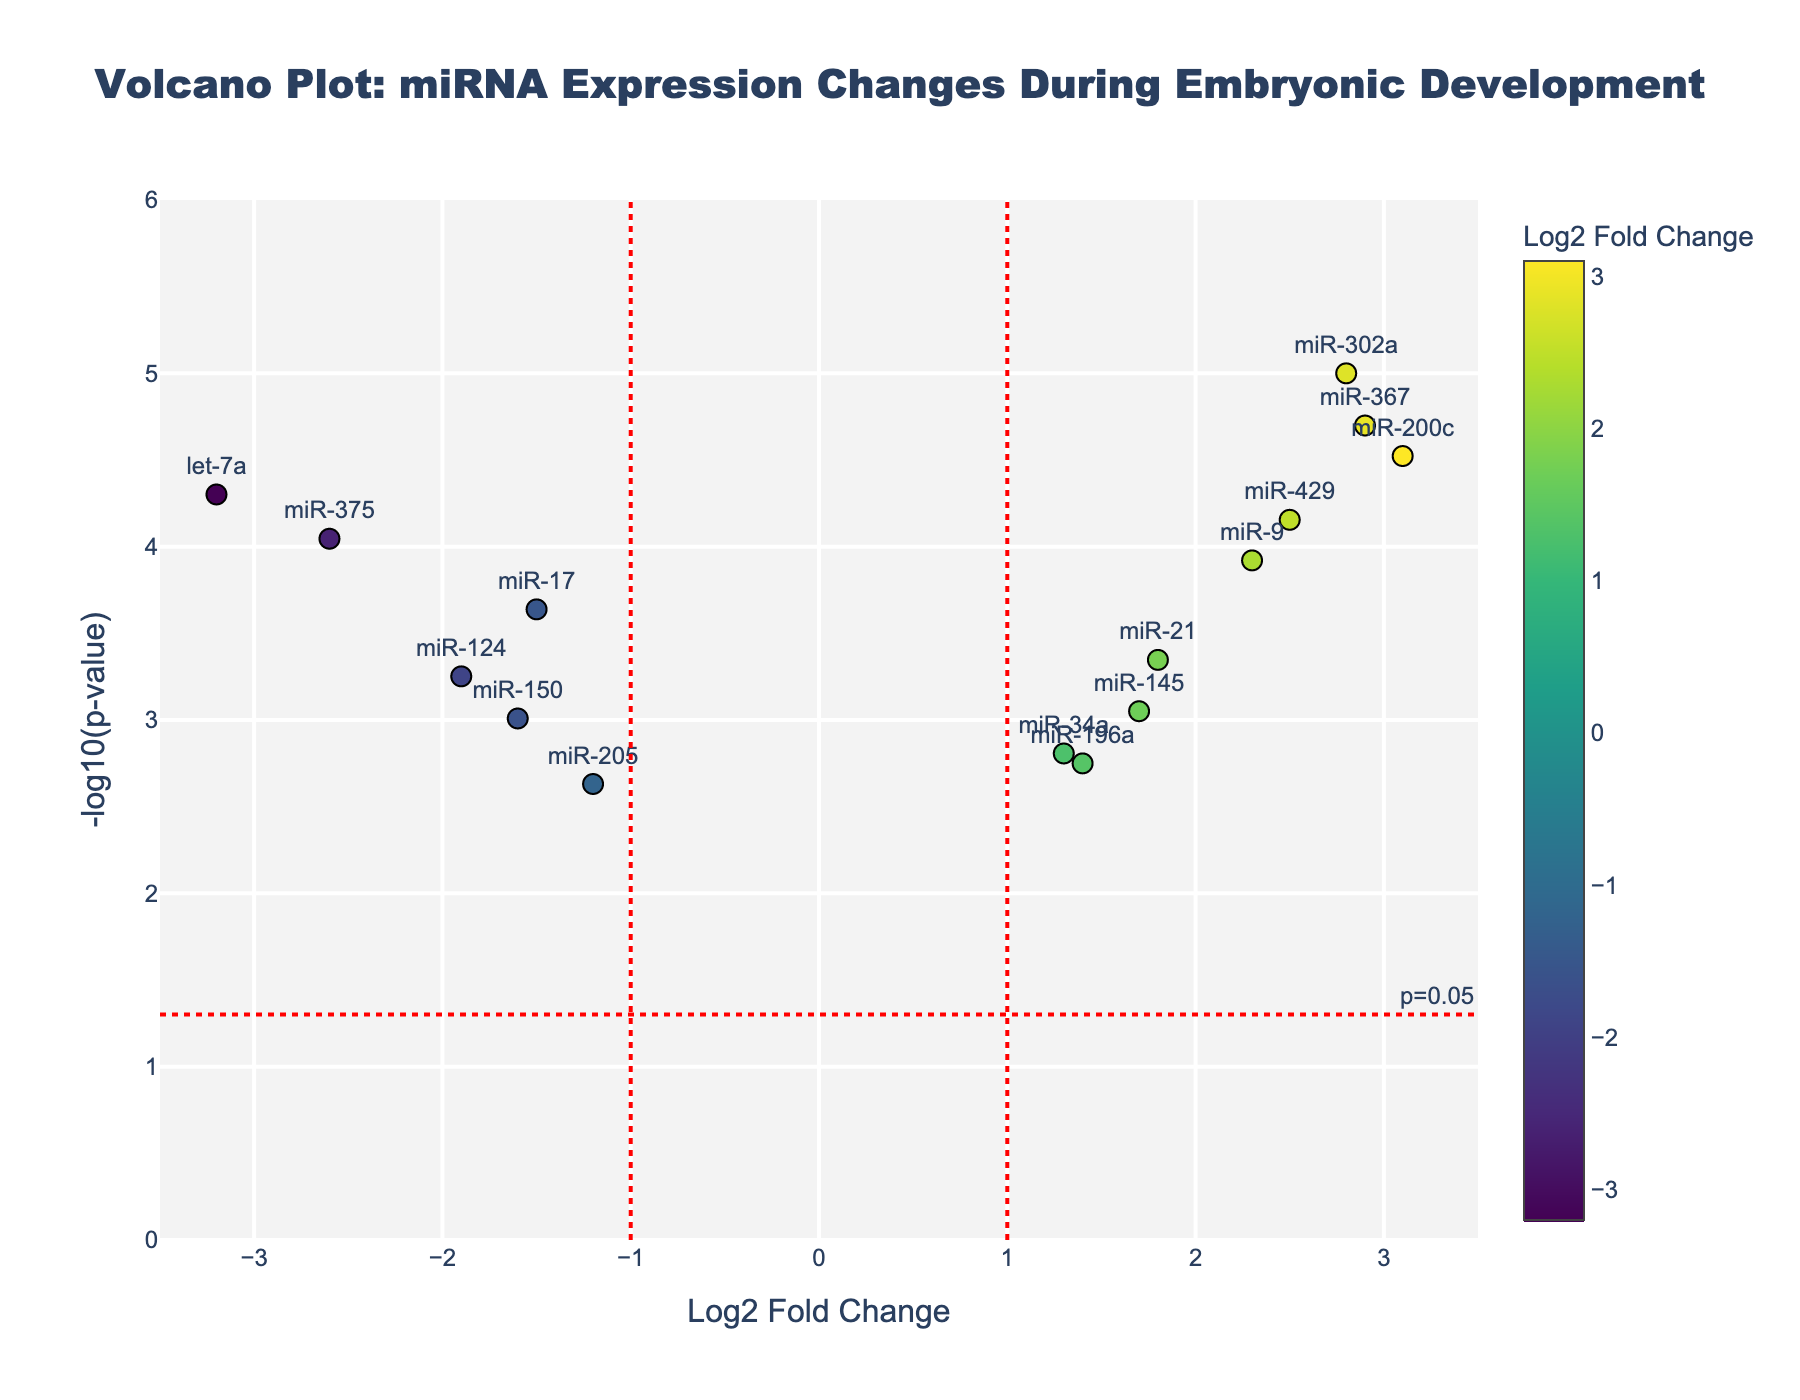How many miRNAs show a Log2 Fold Change greater than 2? To answer this, look at the points on the figure where the x-axis value (Log2 Fold Change) is greater than 2. These points are miR-302a, miR-200c, miR-429, and miR-367.
Answer: 4 Which miRNA has the highest -log10(p-value)? Find the miRNA with the highest value on the y-axis (-log10(p-value)). In this case, it's miR-302a.
Answer: miR-302a What is the general trend of miR-17 in terms of Log2 Fold Change and p-value? Locate miR-17 on the plot. It has a negative Log2 Fold Change and a -log10(p-value) greater than 2, indicating it is down-regulated with a significant p-value.
Answer: Down-regulated with significant p-value Which miRNAs lie exactly on the vertical lines for Log2 Fold Change of -1 and 1? Check the points intersecting the vertical lines at x = -1 and x = 1. miR-145 lies on the line x = 1. There's no miRNA on the line x = -1.
Answer: miR-145 Do any miRNAs fall below the horizontal line indicating p=0.05? The horizontal line represents -log10(0.05). Check the points below this line. In this case, there are no miRNAs below this line.
Answer: No Which miRNA is closest to having a Log2 Fold Change of 0? Find the point nearest to x = 0. The closest miRNA to this point is miR-205.
Answer: miR-205 Compare the Log2 Fold Change values of miR-200c and miR-124. Which is higher? Identify the x-position of miR-200c and miR-124. miR-200c has a Log2 Fold Change of 3.1, while miR-124 has a Log2 Fold Change of -1.9.
Answer: miR-200c What is the Log2 Fold Change and p-value for miR-9? Locate miR-9 and read its plot data. It has a Log2 Fold Change of 2.3 and a p-value shown by the position along the y-axis. Refer to hover text for exact values: Log2FC: 2.3, p-value: 1.2e-4.
Answer: Log2FC: 2.3, p-value: 0.00012 How many miRNAs have a significant p-value (p < 0.05) but a Log2 Fold Change below 1? Locate points below the horizontal line and check the Log2 Fold Change is below 1. miR-196a, miR-205, miR-34a have p < 0.05 but Log2FC < 1.
Answer: 3 